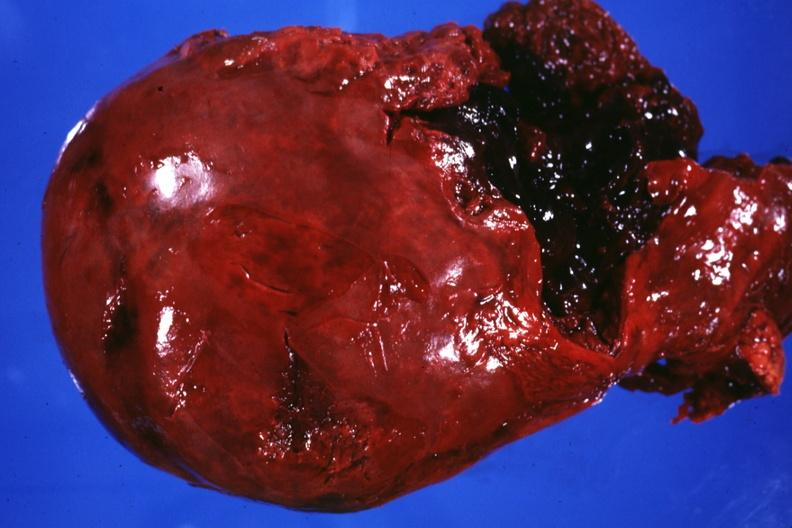s hepatobiliary present?
Answer the question using a single word or phrase. Yes 